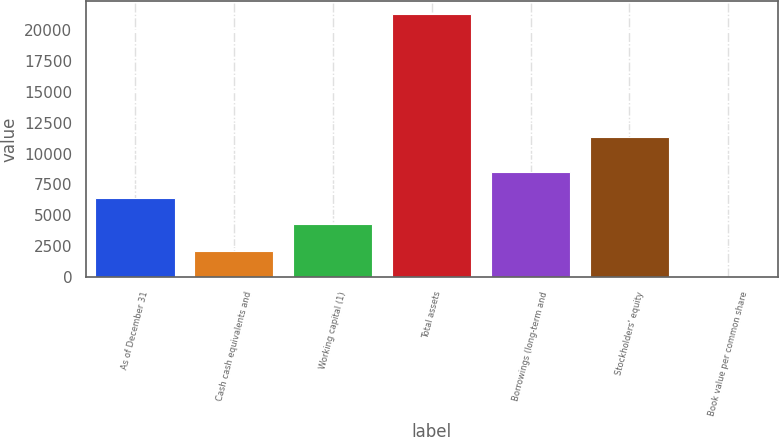Convert chart to OTSL. <chart><loc_0><loc_0><loc_500><loc_500><bar_chart><fcel>As of December 31<fcel>Cash cash equivalents and<fcel>Working capital (1)<fcel>Total assets<fcel>Borrowings (long-term and<fcel>Stockholders' equity<fcel>Book value per common share<nl><fcel>6392.5<fcel>2136.06<fcel>4264.28<fcel>21290<fcel>8520.72<fcel>11353<fcel>7.84<nl></chart> 